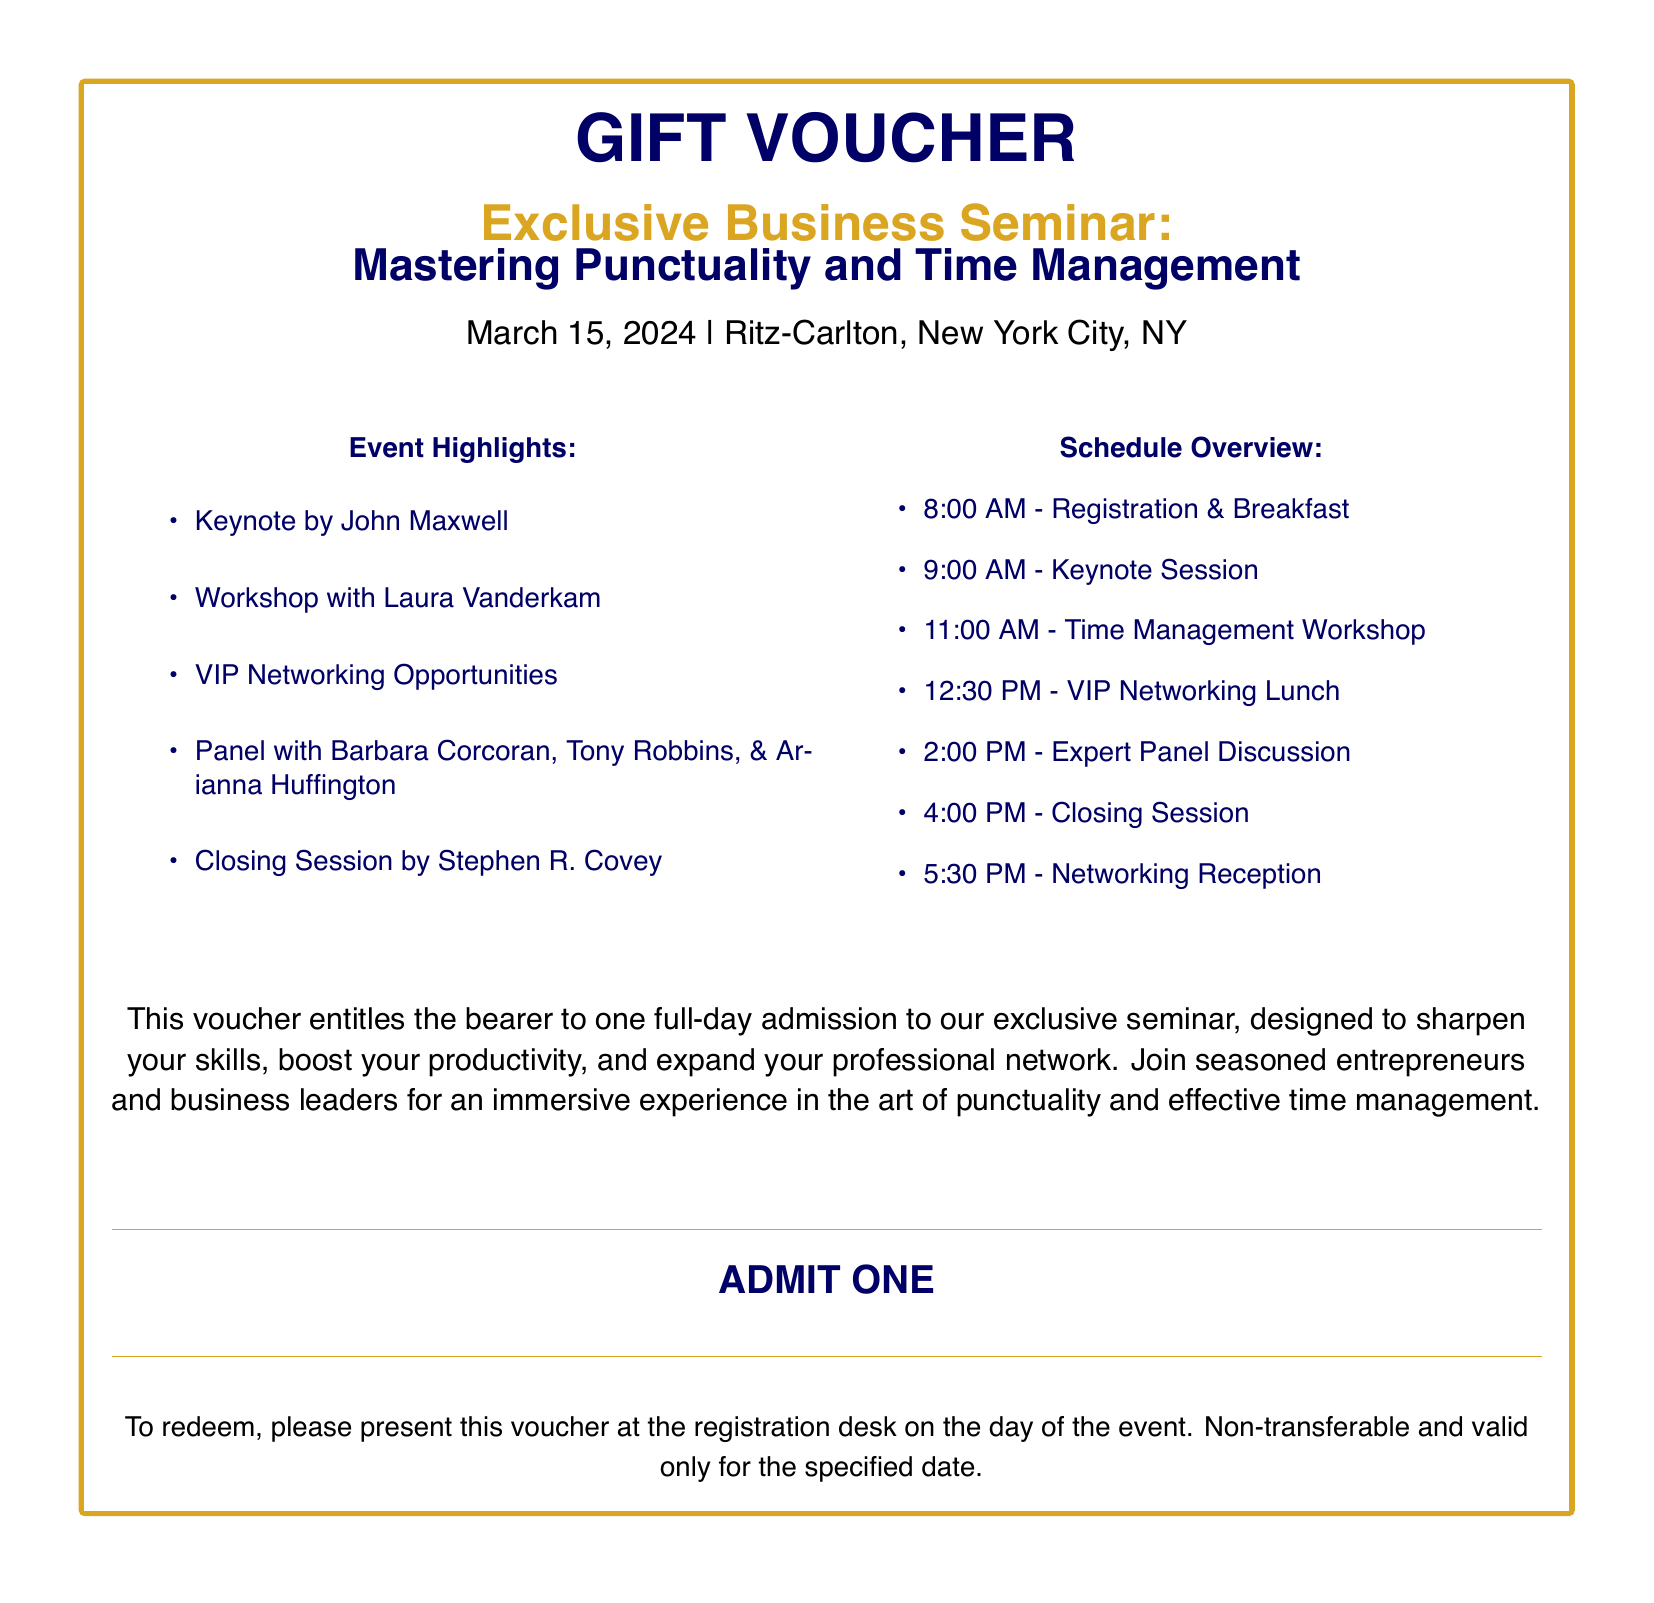What is the title of the seminar? The title of the seminar is found in the header section of the document, which states "Mastering Punctuality and Time Management."
Answer: Mastering Punctuality and Time Management Who is the keynote speaker? This information is listed under the event highlights as the first item, indicating John Maxwell as the keynote speaker.
Answer: John Maxwell What date is the seminar scheduled? The date of the seminar is mentioned clearly at the top of the document, specified as March 15, 2024.
Answer: March 15, 2024 What time does the registration start? The schedule overview provides the time for registration, which starts at 8:00 AM.
Answer: 8:00 AM How many speakers are mentioned in the panel? The event highlights indicate a panel consisting of three speakers: Barbara Corcoran, Tony Robbins, and Arianna Huffington.
Answer: Three What is the location of the seminar? The venue is stated at the beginning of the document, listing Ritz-Carlton, New York City, NY as the location.
Answer: Ritz-Carlton, New York City, NY Is the gift voucher transferable? The document specifies the terms regarding the voucher, stating it is non-transferable.
Answer: Non-transferable What is included for VIPs during lunch? The schedule indicates a "VIP Networking Lunch," indicating special arrangements for VIPs.
Answer: VIP Networking Lunch What is the closing session speaker's name? The closing session speaker's name is mentioned last in the event highlights as Stephen R. Covey.
Answer: Stephen R. Covey 